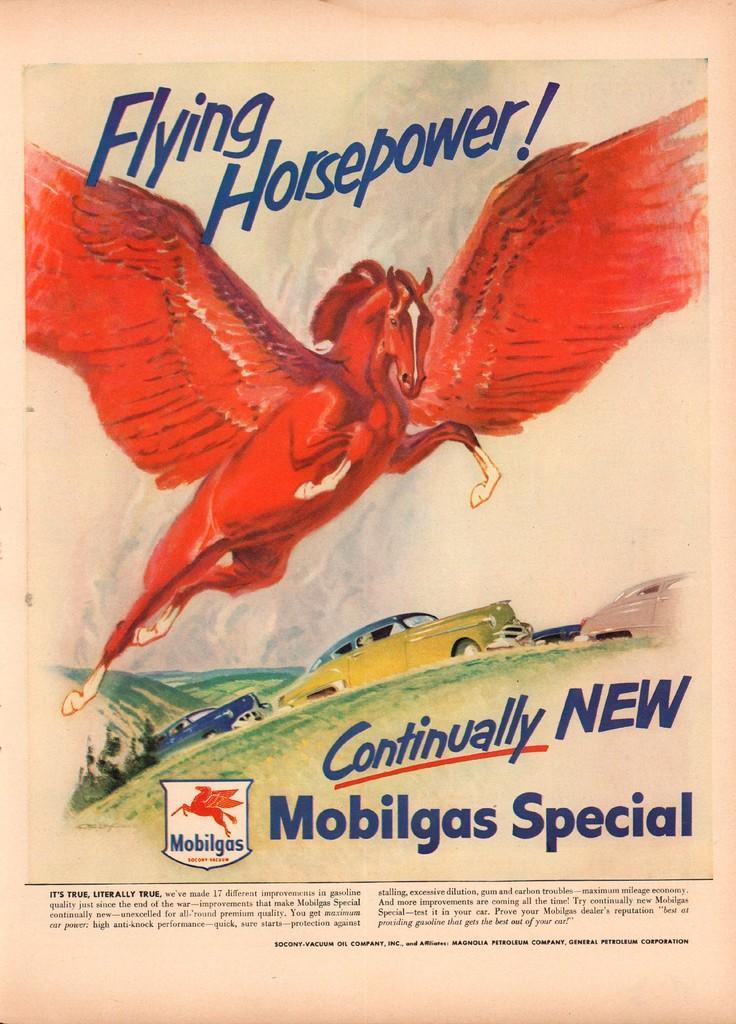Please provide a concise description of this image. In this picture we can see a paper and on the paper there is a flying horse, cars and hills and on the paper it is written something and a logo. 